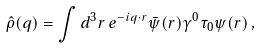<formula> <loc_0><loc_0><loc_500><loc_500>\hat { \rho } ( { q } ) = \int d ^ { 3 } r \, e ^ { - i { q } \cdot { r } } \bar { \psi } ( { r } ) \gamma ^ { 0 } \tau _ { 0 } \psi ( { r } ) \, ,</formula> 